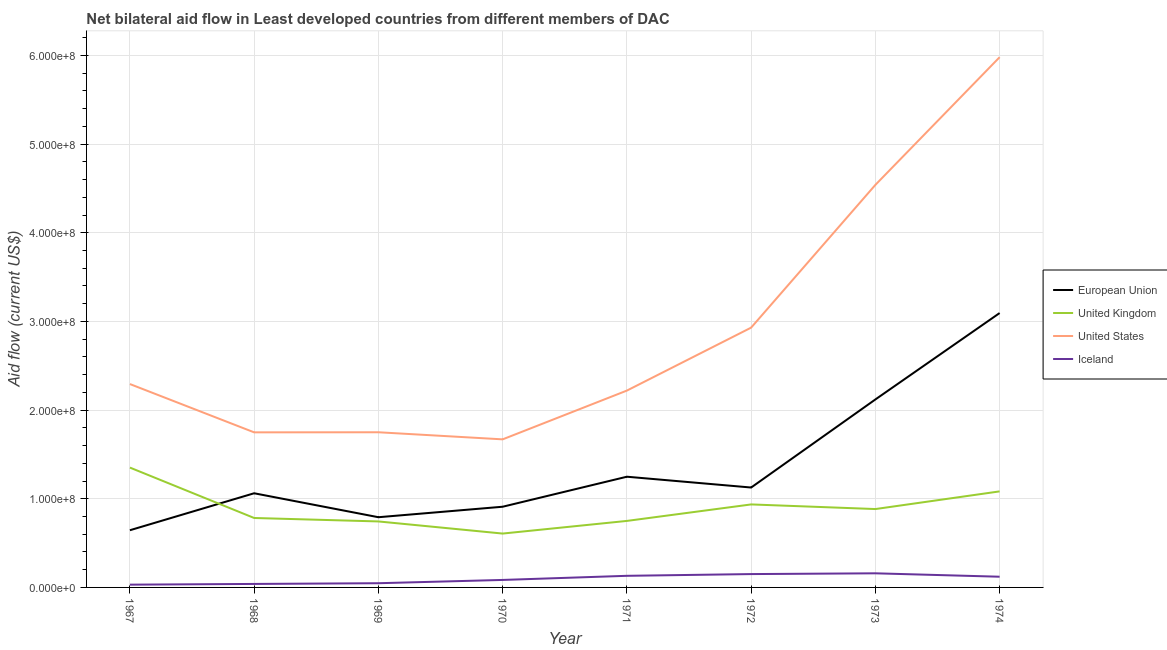How many different coloured lines are there?
Make the answer very short. 4. Does the line corresponding to amount of aid given by us intersect with the line corresponding to amount of aid given by uk?
Ensure brevity in your answer.  No. What is the amount of aid given by us in 1969?
Provide a succinct answer. 1.75e+08. Across all years, what is the maximum amount of aid given by us?
Provide a short and direct response. 5.98e+08. Across all years, what is the minimum amount of aid given by eu?
Offer a terse response. 6.45e+07. In which year was the amount of aid given by uk minimum?
Give a very brief answer. 1970. What is the total amount of aid given by us in the graph?
Provide a succinct answer. 2.31e+09. What is the difference between the amount of aid given by eu in 1973 and that in 1974?
Your answer should be very brief. -9.74e+07. What is the difference between the amount of aid given by us in 1969 and the amount of aid given by eu in 1973?
Offer a very short reply. -3.70e+07. What is the average amount of aid given by iceland per year?
Provide a succinct answer. 9.55e+06. In the year 1974, what is the difference between the amount of aid given by iceland and amount of aid given by uk?
Your answer should be compact. -9.62e+07. What is the ratio of the amount of aid given by eu in 1967 to that in 1974?
Provide a short and direct response. 0.21. Is the amount of aid given by eu in 1969 less than that in 1973?
Ensure brevity in your answer.  Yes. Is the difference between the amount of aid given by eu in 1973 and 1974 greater than the difference between the amount of aid given by us in 1973 and 1974?
Give a very brief answer. Yes. What is the difference between the highest and the second highest amount of aid given by eu?
Your answer should be compact. 9.74e+07. What is the difference between the highest and the lowest amount of aid given by uk?
Keep it short and to the point. 7.44e+07. Is the sum of the amount of aid given by eu in 1968 and 1974 greater than the maximum amount of aid given by uk across all years?
Give a very brief answer. Yes. Is it the case that in every year, the sum of the amount of aid given by us and amount of aid given by uk is greater than the sum of amount of aid given by iceland and amount of aid given by eu?
Provide a short and direct response. No. How many years are there in the graph?
Keep it short and to the point. 8. What is the difference between two consecutive major ticks on the Y-axis?
Offer a terse response. 1.00e+08. Are the values on the major ticks of Y-axis written in scientific E-notation?
Offer a very short reply. Yes. Does the graph contain any zero values?
Make the answer very short. No. What is the title of the graph?
Your response must be concise. Net bilateral aid flow in Least developed countries from different members of DAC. Does "Fourth 20% of population" appear as one of the legend labels in the graph?
Ensure brevity in your answer.  No. What is the Aid flow (current US$) in European Union in 1967?
Your response must be concise. 6.45e+07. What is the Aid flow (current US$) in United Kingdom in 1967?
Keep it short and to the point. 1.35e+08. What is the Aid flow (current US$) of United States in 1967?
Provide a succinct answer. 2.29e+08. What is the Aid flow (current US$) of Iceland in 1967?
Give a very brief answer. 3.12e+06. What is the Aid flow (current US$) of European Union in 1968?
Your response must be concise. 1.06e+08. What is the Aid flow (current US$) in United Kingdom in 1968?
Give a very brief answer. 7.83e+07. What is the Aid flow (current US$) in United States in 1968?
Ensure brevity in your answer.  1.75e+08. What is the Aid flow (current US$) in Iceland in 1968?
Keep it short and to the point. 3.94e+06. What is the Aid flow (current US$) in European Union in 1969?
Offer a very short reply. 7.92e+07. What is the Aid flow (current US$) of United Kingdom in 1969?
Give a very brief answer. 7.44e+07. What is the Aid flow (current US$) of United States in 1969?
Offer a very short reply. 1.75e+08. What is the Aid flow (current US$) of Iceland in 1969?
Provide a short and direct response. 4.74e+06. What is the Aid flow (current US$) in European Union in 1970?
Keep it short and to the point. 9.10e+07. What is the Aid flow (current US$) of United Kingdom in 1970?
Your answer should be very brief. 6.08e+07. What is the Aid flow (current US$) in United States in 1970?
Give a very brief answer. 1.67e+08. What is the Aid flow (current US$) of Iceland in 1970?
Offer a terse response. 8.45e+06. What is the Aid flow (current US$) of European Union in 1971?
Provide a short and direct response. 1.25e+08. What is the Aid flow (current US$) of United Kingdom in 1971?
Offer a terse response. 7.50e+07. What is the Aid flow (current US$) of United States in 1971?
Provide a short and direct response. 2.22e+08. What is the Aid flow (current US$) of Iceland in 1971?
Make the answer very short. 1.31e+07. What is the Aid flow (current US$) of European Union in 1972?
Your answer should be compact. 1.13e+08. What is the Aid flow (current US$) of United Kingdom in 1972?
Provide a short and direct response. 9.36e+07. What is the Aid flow (current US$) of United States in 1972?
Your answer should be very brief. 2.93e+08. What is the Aid flow (current US$) in Iceland in 1972?
Your answer should be compact. 1.50e+07. What is the Aid flow (current US$) of European Union in 1973?
Your answer should be very brief. 2.12e+08. What is the Aid flow (current US$) of United Kingdom in 1973?
Provide a succinct answer. 8.84e+07. What is the Aid flow (current US$) of United States in 1973?
Provide a short and direct response. 4.54e+08. What is the Aid flow (current US$) of Iceland in 1973?
Your answer should be compact. 1.59e+07. What is the Aid flow (current US$) in European Union in 1974?
Provide a succinct answer. 3.09e+08. What is the Aid flow (current US$) of United Kingdom in 1974?
Your answer should be very brief. 1.08e+08. What is the Aid flow (current US$) in United States in 1974?
Provide a succinct answer. 5.98e+08. What is the Aid flow (current US$) in Iceland in 1974?
Your answer should be compact. 1.21e+07. Across all years, what is the maximum Aid flow (current US$) of European Union?
Ensure brevity in your answer.  3.09e+08. Across all years, what is the maximum Aid flow (current US$) of United Kingdom?
Offer a terse response. 1.35e+08. Across all years, what is the maximum Aid flow (current US$) in United States?
Ensure brevity in your answer.  5.98e+08. Across all years, what is the maximum Aid flow (current US$) in Iceland?
Provide a short and direct response. 1.59e+07. Across all years, what is the minimum Aid flow (current US$) of European Union?
Give a very brief answer. 6.45e+07. Across all years, what is the minimum Aid flow (current US$) in United Kingdom?
Offer a terse response. 6.08e+07. Across all years, what is the minimum Aid flow (current US$) in United States?
Make the answer very short. 1.67e+08. Across all years, what is the minimum Aid flow (current US$) of Iceland?
Provide a short and direct response. 3.12e+06. What is the total Aid flow (current US$) of European Union in the graph?
Provide a short and direct response. 1.10e+09. What is the total Aid flow (current US$) in United Kingdom in the graph?
Offer a very short reply. 7.14e+08. What is the total Aid flow (current US$) in United States in the graph?
Give a very brief answer. 2.31e+09. What is the total Aid flow (current US$) of Iceland in the graph?
Make the answer very short. 7.64e+07. What is the difference between the Aid flow (current US$) in European Union in 1967 and that in 1968?
Offer a terse response. -4.17e+07. What is the difference between the Aid flow (current US$) of United Kingdom in 1967 and that in 1968?
Give a very brief answer. 5.68e+07. What is the difference between the Aid flow (current US$) in United States in 1967 and that in 1968?
Your answer should be very brief. 5.45e+07. What is the difference between the Aid flow (current US$) in Iceland in 1967 and that in 1968?
Give a very brief answer. -8.20e+05. What is the difference between the Aid flow (current US$) in European Union in 1967 and that in 1969?
Provide a succinct answer. -1.47e+07. What is the difference between the Aid flow (current US$) in United Kingdom in 1967 and that in 1969?
Your answer should be compact. 6.07e+07. What is the difference between the Aid flow (current US$) of United States in 1967 and that in 1969?
Offer a very short reply. 5.44e+07. What is the difference between the Aid flow (current US$) in Iceland in 1967 and that in 1969?
Provide a succinct answer. -1.62e+06. What is the difference between the Aid flow (current US$) of European Union in 1967 and that in 1970?
Your response must be concise. -2.65e+07. What is the difference between the Aid flow (current US$) in United Kingdom in 1967 and that in 1970?
Make the answer very short. 7.44e+07. What is the difference between the Aid flow (current US$) in United States in 1967 and that in 1970?
Your response must be concise. 6.24e+07. What is the difference between the Aid flow (current US$) of Iceland in 1967 and that in 1970?
Keep it short and to the point. -5.33e+06. What is the difference between the Aid flow (current US$) of European Union in 1967 and that in 1971?
Give a very brief answer. -6.04e+07. What is the difference between the Aid flow (current US$) of United Kingdom in 1967 and that in 1971?
Provide a short and direct response. 6.02e+07. What is the difference between the Aid flow (current US$) of United States in 1967 and that in 1971?
Provide a short and direct response. 7.37e+06. What is the difference between the Aid flow (current US$) in Iceland in 1967 and that in 1971?
Offer a very short reply. -9.97e+06. What is the difference between the Aid flow (current US$) in European Union in 1967 and that in 1972?
Offer a very short reply. -4.82e+07. What is the difference between the Aid flow (current US$) in United Kingdom in 1967 and that in 1972?
Provide a short and direct response. 4.16e+07. What is the difference between the Aid flow (current US$) in United States in 1967 and that in 1972?
Ensure brevity in your answer.  -6.36e+07. What is the difference between the Aid flow (current US$) of Iceland in 1967 and that in 1972?
Provide a succinct answer. -1.19e+07. What is the difference between the Aid flow (current US$) in European Union in 1967 and that in 1973?
Ensure brevity in your answer.  -1.47e+08. What is the difference between the Aid flow (current US$) in United Kingdom in 1967 and that in 1973?
Give a very brief answer. 4.68e+07. What is the difference between the Aid flow (current US$) of United States in 1967 and that in 1973?
Ensure brevity in your answer.  -2.25e+08. What is the difference between the Aid flow (current US$) in Iceland in 1967 and that in 1973?
Offer a very short reply. -1.28e+07. What is the difference between the Aid flow (current US$) in European Union in 1967 and that in 1974?
Provide a short and direct response. -2.45e+08. What is the difference between the Aid flow (current US$) of United Kingdom in 1967 and that in 1974?
Keep it short and to the point. 2.68e+07. What is the difference between the Aid flow (current US$) in United States in 1967 and that in 1974?
Your answer should be compact. -3.69e+08. What is the difference between the Aid flow (current US$) in Iceland in 1967 and that in 1974?
Provide a succinct answer. -8.95e+06. What is the difference between the Aid flow (current US$) of European Union in 1968 and that in 1969?
Your answer should be compact. 2.70e+07. What is the difference between the Aid flow (current US$) of United Kingdom in 1968 and that in 1969?
Offer a terse response. 3.90e+06. What is the difference between the Aid flow (current US$) in Iceland in 1968 and that in 1969?
Ensure brevity in your answer.  -8.00e+05. What is the difference between the Aid flow (current US$) of European Union in 1968 and that in 1970?
Offer a terse response. 1.52e+07. What is the difference between the Aid flow (current US$) of United Kingdom in 1968 and that in 1970?
Offer a very short reply. 1.76e+07. What is the difference between the Aid flow (current US$) of United States in 1968 and that in 1970?
Give a very brief answer. 7.90e+06. What is the difference between the Aid flow (current US$) of Iceland in 1968 and that in 1970?
Offer a terse response. -4.51e+06. What is the difference between the Aid flow (current US$) of European Union in 1968 and that in 1971?
Offer a very short reply. -1.87e+07. What is the difference between the Aid flow (current US$) of United Kingdom in 1968 and that in 1971?
Your response must be concise. 3.31e+06. What is the difference between the Aid flow (current US$) in United States in 1968 and that in 1971?
Keep it short and to the point. -4.71e+07. What is the difference between the Aid flow (current US$) in Iceland in 1968 and that in 1971?
Make the answer very short. -9.15e+06. What is the difference between the Aid flow (current US$) of European Union in 1968 and that in 1972?
Offer a very short reply. -6.47e+06. What is the difference between the Aid flow (current US$) in United Kingdom in 1968 and that in 1972?
Keep it short and to the point. -1.53e+07. What is the difference between the Aid flow (current US$) in United States in 1968 and that in 1972?
Your answer should be very brief. -1.18e+08. What is the difference between the Aid flow (current US$) in Iceland in 1968 and that in 1972?
Your response must be concise. -1.11e+07. What is the difference between the Aid flow (current US$) in European Union in 1968 and that in 1973?
Your answer should be compact. -1.06e+08. What is the difference between the Aid flow (current US$) in United Kingdom in 1968 and that in 1973?
Your response must be concise. -1.01e+07. What is the difference between the Aid flow (current US$) of United States in 1968 and that in 1973?
Your answer should be compact. -2.79e+08. What is the difference between the Aid flow (current US$) of Iceland in 1968 and that in 1973?
Ensure brevity in your answer.  -1.20e+07. What is the difference between the Aid flow (current US$) in European Union in 1968 and that in 1974?
Give a very brief answer. -2.03e+08. What is the difference between the Aid flow (current US$) of United Kingdom in 1968 and that in 1974?
Keep it short and to the point. -3.00e+07. What is the difference between the Aid flow (current US$) of United States in 1968 and that in 1974?
Your answer should be compact. -4.23e+08. What is the difference between the Aid flow (current US$) of Iceland in 1968 and that in 1974?
Give a very brief answer. -8.13e+06. What is the difference between the Aid flow (current US$) of European Union in 1969 and that in 1970?
Your answer should be compact. -1.18e+07. What is the difference between the Aid flow (current US$) of United Kingdom in 1969 and that in 1970?
Your response must be concise. 1.37e+07. What is the difference between the Aid flow (current US$) in United States in 1969 and that in 1970?
Keep it short and to the point. 8.00e+06. What is the difference between the Aid flow (current US$) of Iceland in 1969 and that in 1970?
Make the answer very short. -3.71e+06. What is the difference between the Aid flow (current US$) of European Union in 1969 and that in 1971?
Keep it short and to the point. -4.57e+07. What is the difference between the Aid flow (current US$) of United Kingdom in 1969 and that in 1971?
Provide a succinct answer. -5.90e+05. What is the difference between the Aid flow (current US$) in United States in 1969 and that in 1971?
Your response must be concise. -4.70e+07. What is the difference between the Aid flow (current US$) of Iceland in 1969 and that in 1971?
Provide a short and direct response. -8.35e+06. What is the difference between the Aid flow (current US$) of European Union in 1969 and that in 1972?
Your answer should be very brief. -3.35e+07. What is the difference between the Aid flow (current US$) in United Kingdom in 1969 and that in 1972?
Your response must be concise. -1.92e+07. What is the difference between the Aid flow (current US$) of United States in 1969 and that in 1972?
Make the answer very short. -1.18e+08. What is the difference between the Aid flow (current US$) of Iceland in 1969 and that in 1972?
Make the answer very short. -1.03e+07. What is the difference between the Aid flow (current US$) in European Union in 1969 and that in 1973?
Your answer should be very brief. -1.33e+08. What is the difference between the Aid flow (current US$) in United Kingdom in 1969 and that in 1973?
Provide a succinct answer. -1.40e+07. What is the difference between the Aid flow (current US$) in United States in 1969 and that in 1973?
Your answer should be very brief. -2.79e+08. What is the difference between the Aid flow (current US$) of Iceland in 1969 and that in 1973?
Provide a succinct answer. -1.12e+07. What is the difference between the Aid flow (current US$) of European Union in 1969 and that in 1974?
Ensure brevity in your answer.  -2.30e+08. What is the difference between the Aid flow (current US$) in United Kingdom in 1969 and that in 1974?
Your answer should be compact. -3.39e+07. What is the difference between the Aid flow (current US$) in United States in 1969 and that in 1974?
Your answer should be compact. -4.23e+08. What is the difference between the Aid flow (current US$) of Iceland in 1969 and that in 1974?
Give a very brief answer. -7.33e+06. What is the difference between the Aid flow (current US$) in European Union in 1970 and that in 1971?
Offer a very short reply. -3.38e+07. What is the difference between the Aid flow (current US$) of United Kingdom in 1970 and that in 1971?
Your answer should be compact. -1.43e+07. What is the difference between the Aid flow (current US$) of United States in 1970 and that in 1971?
Ensure brevity in your answer.  -5.50e+07. What is the difference between the Aid flow (current US$) of Iceland in 1970 and that in 1971?
Your answer should be very brief. -4.64e+06. What is the difference between the Aid flow (current US$) in European Union in 1970 and that in 1972?
Your response must be concise. -2.17e+07. What is the difference between the Aid flow (current US$) of United Kingdom in 1970 and that in 1972?
Offer a very short reply. -3.29e+07. What is the difference between the Aid flow (current US$) in United States in 1970 and that in 1972?
Make the answer very short. -1.26e+08. What is the difference between the Aid flow (current US$) of Iceland in 1970 and that in 1972?
Make the answer very short. -6.60e+06. What is the difference between the Aid flow (current US$) of European Union in 1970 and that in 1973?
Offer a very short reply. -1.21e+08. What is the difference between the Aid flow (current US$) of United Kingdom in 1970 and that in 1973?
Provide a succinct answer. -2.76e+07. What is the difference between the Aid flow (current US$) of United States in 1970 and that in 1973?
Your answer should be very brief. -2.87e+08. What is the difference between the Aid flow (current US$) of Iceland in 1970 and that in 1973?
Your answer should be compact. -7.46e+06. What is the difference between the Aid flow (current US$) in European Union in 1970 and that in 1974?
Give a very brief answer. -2.18e+08. What is the difference between the Aid flow (current US$) in United Kingdom in 1970 and that in 1974?
Ensure brevity in your answer.  -4.76e+07. What is the difference between the Aid flow (current US$) in United States in 1970 and that in 1974?
Provide a succinct answer. -4.31e+08. What is the difference between the Aid flow (current US$) in Iceland in 1970 and that in 1974?
Your answer should be very brief. -3.62e+06. What is the difference between the Aid flow (current US$) in European Union in 1971 and that in 1972?
Give a very brief answer. 1.22e+07. What is the difference between the Aid flow (current US$) of United Kingdom in 1971 and that in 1972?
Your answer should be very brief. -1.86e+07. What is the difference between the Aid flow (current US$) in United States in 1971 and that in 1972?
Make the answer very short. -7.10e+07. What is the difference between the Aid flow (current US$) of Iceland in 1971 and that in 1972?
Offer a terse response. -1.96e+06. What is the difference between the Aid flow (current US$) in European Union in 1971 and that in 1973?
Offer a terse response. -8.71e+07. What is the difference between the Aid flow (current US$) of United Kingdom in 1971 and that in 1973?
Keep it short and to the point. -1.34e+07. What is the difference between the Aid flow (current US$) of United States in 1971 and that in 1973?
Provide a succinct answer. -2.32e+08. What is the difference between the Aid flow (current US$) of Iceland in 1971 and that in 1973?
Keep it short and to the point. -2.82e+06. What is the difference between the Aid flow (current US$) in European Union in 1971 and that in 1974?
Give a very brief answer. -1.85e+08. What is the difference between the Aid flow (current US$) of United Kingdom in 1971 and that in 1974?
Keep it short and to the point. -3.33e+07. What is the difference between the Aid flow (current US$) in United States in 1971 and that in 1974?
Provide a short and direct response. -3.76e+08. What is the difference between the Aid flow (current US$) of Iceland in 1971 and that in 1974?
Give a very brief answer. 1.02e+06. What is the difference between the Aid flow (current US$) in European Union in 1972 and that in 1973?
Your answer should be very brief. -9.93e+07. What is the difference between the Aid flow (current US$) in United Kingdom in 1972 and that in 1973?
Your answer should be compact. 5.22e+06. What is the difference between the Aid flow (current US$) of United States in 1972 and that in 1973?
Make the answer very short. -1.61e+08. What is the difference between the Aid flow (current US$) in Iceland in 1972 and that in 1973?
Make the answer very short. -8.60e+05. What is the difference between the Aid flow (current US$) in European Union in 1972 and that in 1974?
Ensure brevity in your answer.  -1.97e+08. What is the difference between the Aid flow (current US$) in United Kingdom in 1972 and that in 1974?
Your answer should be very brief. -1.47e+07. What is the difference between the Aid flow (current US$) of United States in 1972 and that in 1974?
Provide a short and direct response. -3.05e+08. What is the difference between the Aid flow (current US$) of Iceland in 1972 and that in 1974?
Keep it short and to the point. 2.98e+06. What is the difference between the Aid flow (current US$) in European Union in 1973 and that in 1974?
Offer a terse response. -9.74e+07. What is the difference between the Aid flow (current US$) of United Kingdom in 1973 and that in 1974?
Give a very brief answer. -1.99e+07. What is the difference between the Aid flow (current US$) in United States in 1973 and that in 1974?
Your response must be concise. -1.44e+08. What is the difference between the Aid flow (current US$) in Iceland in 1973 and that in 1974?
Provide a succinct answer. 3.84e+06. What is the difference between the Aid flow (current US$) in European Union in 1967 and the Aid flow (current US$) in United Kingdom in 1968?
Keep it short and to the point. -1.38e+07. What is the difference between the Aid flow (current US$) of European Union in 1967 and the Aid flow (current US$) of United States in 1968?
Ensure brevity in your answer.  -1.10e+08. What is the difference between the Aid flow (current US$) in European Union in 1967 and the Aid flow (current US$) in Iceland in 1968?
Provide a succinct answer. 6.06e+07. What is the difference between the Aid flow (current US$) in United Kingdom in 1967 and the Aid flow (current US$) in United States in 1968?
Offer a terse response. -3.97e+07. What is the difference between the Aid flow (current US$) of United Kingdom in 1967 and the Aid flow (current US$) of Iceland in 1968?
Offer a terse response. 1.31e+08. What is the difference between the Aid flow (current US$) in United States in 1967 and the Aid flow (current US$) in Iceland in 1968?
Your answer should be very brief. 2.25e+08. What is the difference between the Aid flow (current US$) of European Union in 1967 and the Aid flow (current US$) of United Kingdom in 1969?
Offer a very short reply. -9.91e+06. What is the difference between the Aid flow (current US$) of European Union in 1967 and the Aid flow (current US$) of United States in 1969?
Your answer should be compact. -1.10e+08. What is the difference between the Aid flow (current US$) of European Union in 1967 and the Aid flow (current US$) of Iceland in 1969?
Provide a succinct answer. 5.98e+07. What is the difference between the Aid flow (current US$) of United Kingdom in 1967 and the Aid flow (current US$) of United States in 1969?
Offer a terse response. -3.98e+07. What is the difference between the Aid flow (current US$) in United Kingdom in 1967 and the Aid flow (current US$) in Iceland in 1969?
Make the answer very short. 1.30e+08. What is the difference between the Aid flow (current US$) in United States in 1967 and the Aid flow (current US$) in Iceland in 1969?
Provide a succinct answer. 2.25e+08. What is the difference between the Aid flow (current US$) in European Union in 1967 and the Aid flow (current US$) in United Kingdom in 1970?
Provide a succinct answer. 3.76e+06. What is the difference between the Aid flow (current US$) in European Union in 1967 and the Aid flow (current US$) in United States in 1970?
Offer a very short reply. -1.02e+08. What is the difference between the Aid flow (current US$) of European Union in 1967 and the Aid flow (current US$) of Iceland in 1970?
Your response must be concise. 5.61e+07. What is the difference between the Aid flow (current US$) of United Kingdom in 1967 and the Aid flow (current US$) of United States in 1970?
Make the answer very short. -3.18e+07. What is the difference between the Aid flow (current US$) of United Kingdom in 1967 and the Aid flow (current US$) of Iceland in 1970?
Offer a very short reply. 1.27e+08. What is the difference between the Aid flow (current US$) of United States in 1967 and the Aid flow (current US$) of Iceland in 1970?
Ensure brevity in your answer.  2.21e+08. What is the difference between the Aid flow (current US$) in European Union in 1967 and the Aid flow (current US$) in United Kingdom in 1971?
Give a very brief answer. -1.05e+07. What is the difference between the Aid flow (current US$) of European Union in 1967 and the Aid flow (current US$) of United States in 1971?
Keep it short and to the point. -1.57e+08. What is the difference between the Aid flow (current US$) in European Union in 1967 and the Aid flow (current US$) in Iceland in 1971?
Your answer should be very brief. 5.14e+07. What is the difference between the Aid flow (current US$) in United Kingdom in 1967 and the Aid flow (current US$) in United States in 1971?
Offer a terse response. -8.68e+07. What is the difference between the Aid flow (current US$) in United Kingdom in 1967 and the Aid flow (current US$) in Iceland in 1971?
Your answer should be very brief. 1.22e+08. What is the difference between the Aid flow (current US$) in United States in 1967 and the Aid flow (current US$) in Iceland in 1971?
Ensure brevity in your answer.  2.16e+08. What is the difference between the Aid flow (current US$) in European Union in 1967 and the Aid flow (current US$) in United Kingdom in 1972?
Offer a terse response. -2.91e+07. What is the difference between the Aid flow (current US$) of European Union in 1967 and the Aid flow (current US$) of United States in 1972?
Your response must be concise. -2.28e+08. What is the difference between the Aid flow (current US$) in European Union in 1967 and the Aid flow (current US$) in Iceland in 1972?
Provide a short and direct response. 4.95e+07. What is the difference between the Aid flow (current US$) in United Kingdom in 1967 and the Aid flow (current US$) in United States in 1972?
Give a very brief answer. -1.58e+08. What is the difference between the Aid flow (current US$) in United Kingdom in 1967 and the Aid flow (current US$) in Iceland in 1972?
Your response must be concise. 1.20e+08. What is the difference between the Aid flow (current US$) of United States in 1967 and the Aid flow (current US$) of Iceland in 1972?
Offer a very short reply. 2.14e+08. What is the difference between the Aid flow (current US$) of European Union in 1967 and the Aid flow (current US$) of United Kingdom in 1973?
Your answer should be compact. -2.39e+07. What is the difference between the Aid flow (current US$) in European Union in 1967 and the Aid flow (current US$) in United States in 1973?
Ensure brevity in your answer.  -3.89e+08. What is the difference between the Aid flow (current US$) of European Union in 1967 and the Aid flow (current US$) of Iceland in 1973?
Keep it short and to the point. 4.86e+07. What is the difference between the Aid flow (current US$) in United Kingdom in 1967 and the Aid flow (current US$) in United States in 1973?
Give a very brief answer. -3.19e+08. What is the difference between the Aid flow (current US$) of United Kingdom in 1967 and the Aid flow (current US$) of Iceland in 1973?
Provide a short and direct response. 1.19e+08. What is the difference between the Aid flow (current US$) of United States in 1967 and the Aid flow (current US$) of Iceland in 1973?
Your response must be concise. 2.13e+08. What is the difference between the Aid flow (current US$) in European Union in 1967 and the Aid flow (current US$) in United Kingdom in 1974?
Provide a succinct answer. -4.38e+07. What is the difference between the Aid flow (current US$) of European Union in 1967 and the Aid flow (current US$) of United States in 1974?
Provide a succinct answer. -5.33e+08. What is the difference between the Aid flow (current US$) of European Union in 1967 and the Aid flow (current US$) of Iceland in 1974?
Your answer should be compact. 5.24e+07. What is the difference between the Aid flow (current US$) of United Kingdom in 1967 and the Aid flow (current US$) of United States in 1974?
Keep it short and to the point. -4.63e+08. What is the difference between the Aid flow (current US$) in United Kingdom in 1967 and the Aid flow (current US$) in Iceland in 1974?
Make the answer very short. 1.23e+08. What is the difference between the Aid flow (current US$) of United States in 1967 and the Aid flow (current US$) of Iceland in 1974?
Your answer should be very brief. 2.17e+08. What is the difference between the Aid flow (current US$) in European Union in 1968 and the Aid flow (current US$) in United Kingdom in 1969?
Offer a very short reply. 3.18e+07. What is the difference between the Aid flow (current US$) of European Union in 1968 and the Aid flow (current US$) of United States in 1969?
Your answer should be very brief. -6.88e+07. What is the difference between the Aid flow (current US$) of European Union in 1968 and the Aid flow (current US$) of Iceland in 1969?
Provide a short and direct response. 1.01e+08. What is the difference between the Aid flow (current US$) of United Kingdom in 1968 and the Aid flow (current US$) of United States in 1969?
Offer a terse response. -9.67e+07. What is the difference between the Aid flow (current US$) in United Kingdom in 1968 and the Aid flow (current US$) in Iceland in 1969?
Keep it short and to the point. 7.36e+07. What is the difference between the Aid flow (current US$) in United States in 1968 and the Aid flow (current US$) in Iceland in 1969?
Provide a succinct answer. 1.70e+08. What is the difference between the Aid flow (current US$) of European Union in 1968 and the Aid flow (current US$) of United Kingdom in 1970?
Ensure brevity in your answer.  4.54e+07. What is the difference between the Aid flow (current US$) of European Union in 1968 and the Aid flow (current US$) of United States in 1970?
Give a very brief answer. -6.08e+07. What is the difference between the Aid flow (current US$) of European Union in 1968 and the Aid flow (current US$) of Iceland in 1970?
Your answer should be very brief. 9.78e+07. What is the difference between the Aid flow (current US$) in United Kingdom in 1968 and the Aid flow (current US$) in United States in 1970?
Make the answer very short. -8.87e+07. What is the difference between the Aid flow (current US$) of United Kingdom in 1968 and the Aid flow (current US$) of Iceland in 1970?
Provide a short and direct response. 6.99e+07. What is the difference between the Aid flow (current US$) of United States in 1968 and the Aid flow (current US$) of Iceland in 1970?
Your response must be concise. 1.66e+08. What is the difference between the Aid flow (current US$) in European Union in 1968 and the Aid flow (current US$) in United Kingdom in 1971?
Give a very brief answer. 3.12e+07. What is the difference between the Aid flow (current US$) in European Union in 1968 and the Aid flow (current US$) in United States in 1971?
Give a very brief answer. -1.16e+08. What is the difference between the Aid flow (current US$) of European Union in 1968 and the Aid flow (current US$) of Iceland in 1971?
Your answer should be compact. 9.31e+07. What is the difference between the Aid flow (current US$) in United Kingdom in 1968 and the Aid flow (current US$) in United States in 1971?
Your answer should be very brief. -1.44e+08. What is the difference between the Aid flow (current US$) in United Kingdom in 1968 and the Aid flow (current US$) in Iceland in 1971?
Keep it short and to the point. 6.52e+07. What is the difference between the Aid flow (current US$) of United States in 1968 and the Aid flow (current US$) of Iceland in 1971?
Make the answer very short. 1.62e+08. What is the difference between the Aid flow (current US$) in European Union in 1968 and the Aid flow (current US$) in United Kingdom in 1972?
Your response must be concise. 1.26e+07. What is the difference between the Aid flow (current US$) of European Union in 1968 and the Aid flow (current US$) of United States in 1972?
Offer a terse response. -1.87e+08. What is the difference between the Aid flow (current US$) in European Union in 1968 and the Aid flow (current US$) in Iceland in 1972?
Give a very brief answer. 9.12e+07. What is the difference between the Aid flow (current US$) in United Kingdom in 1968 and the Aid flow (current US$) in United States in 1972?
Offer a very short reply. -2.15e+08. What is the difference between the Aid flow (current US$) in United Kingdom in 1968 and the Aid flow (current US$) in Iceland in 1972?
Ensure brevity in your answer.  6.33e+07. What is the difference between the Aid flow (current US$) in United States in 1968 and the Aid flow (current US$) in Iceland in 1972?
Give a very brief answer. 1.60e+08. What is the difference between the Aid flow (current US$) of European Union in 1968 and the Aid flow (current US$) of United Kingdom in 1973?
Ensure brevity in your answer.  1.78e+07. What is the difference between the Aid flow (current US$) of European Union in 1968 and the Aid flow (current US$) of United States in 1973?
Your answer should be very brief. -3.48e+08. What is the difference between the Aid flow (current US$) of European Union in 1968 and the Aid flow (current US$) of Iceland in 1973?
Provide a short and direct response. 9.03e+07. What is the difference between the Aid flow (current US$) in United Kingdom in 1968 and the Aid flow (current US$) in United States in 1973?
Ensure brevity in your answer.  -3.76e+08. What is the difference between the Aid flow (current US$) in United Kingdom in 1968 and the Aid flow (current US$) in Iceland in 1973?
Keep it short and to the point. 6.24e+07. What is the difference between the Aid flow (current US$) in United States in 1968 and the Aid flow (current US$) in Iceland in 1973?
Offer a terse response. 1.59e+08. What is the difference between the Aid flow (current US$) of European Union in 1968 and the Aid flow (current US$) of United Kingdom in 1974?
Offer a very short reply. -2.12e+06. What is the difference between the Aid flow (current US$) in European Union in 1968 and the Aid flow (current US$) in United States in 1974?
Your answer should be compact. -4.92e+08. What is the difference between the Aid flow (current US$) in European Union in 1968 and the Aid flow (current US$) in Iceland in 1974?
Provide a succinct answer. 9.41e+07. What is the difference between the Aid flow (current US$) of United Kingdom in 1968 and the Aid flow (current US$) of United States in 1974?
Your answer should be very brief. -5.20e+08. What is the difference between the Aid flow (current US$) of United Kingdom in 1968 and the Aid flow (current US$) of Iceland in 1974?
Keep it short and to the point. 6.62e+07. What is the difference between the Aid flow (current US$) in United States in 1968 and the Aid flow (current US$) in Iceland in 1974?
Your answer should be very brief. 1.63e+08. What is the difference between the Aid flow (current US$) of European Union in 1969 and the Aid flow (current US$) of United Kingdom in 1970?
Provide a short and direct response. 1.84e+07. What is the difference between the Aid flow (current US$) in European Union in 1969 and the Aid flow (current US$) in United States in 1970?
Make the answer very short. -8.78e+07. What is the difference between the Aid flow (current US$) in European Union in 1969 and the Aid flow (current US$) in Iceland in 1970?
Your answer should be compact. 7.07e+07. What is the difference between the Aid flow (current US$) in United Kingdom in 1969 and the Aid flow (current US$) in United States in 1970?
Give a very brief answer. -9.26e+07. What is the difference between the Aid flow (current US$) of United Kingdom in 1969 and the Aid flow (current US$) of Iceland in 1970?
Provide a short and direct response. 6.60e+07. What is the difference between the Aid flow (current US$) of United States in 1969 and the Aid flow (current US$) of Iceland in 1970?
Offer a terse response. 1.67e+08. What is the difference between the Aid flow (current US$) of European Union in 1969 and the Aid flow (current US$) of United Kingdom in 1971?
Offer a terse response. 4.17e+06. What is the difference between the Aid flow (current US$) of European Union in 1969 and the Aid flow (current US$) of United States in 1971?
Ensure brevity in your answer.  -1.43e+08. What is the difference between the Aid flow (current US$) of European Union in 1969 and the Aid flow (current US$) of Iceland in 1971?
Keep it short and to the point. 6.61e+07. What is the difference between the Aid flow (current US$) of United Kingdom in 1969 and the Aid flow (current US$) of United States in 1971?
Provide a short and direct response. -1.48e+08. What is the difference between the Aid flow (current US$) of United Kingdom in 1969 and the Aid flow (current US$) of Iceland in 1971?
Keep it short and to the point. 6.13e+07. What is the difference between the Aid flow (current US$) of United States in 1969 and the Aid flow (current US$) of Iceland in 1971?
Offer a terse response. 1.62e+08. What is the difference between the Aid flow (current US$) of European Union in 1969 and the Aid flow (current US$) of United Kingdom in 1972?
Make the answer very short. -1.44e+07. What is the difference between the Aid flow (current US$) in European Union in 1969 and the Aid flow (current US$) in United States in 1972?
Your answer should be very brief. -2.14e+08. What is the difference between the Aid flow (current US$) in European Union in 1969 and the Aid flow (current US$) in Iceland in 1972?
Provide a succinct answer. 6.41e+07. What is the difference between the Aid flow (current US$) of United Kingdom in 1969 and the Aid flow (current US$) of United States in 1972?
Provide a succinct answer. -2.19e+08. What is the difference between the Aid flow (current US$) of United Kingdom in 1969 and the Aid flow (current US$) of Iceland in 1972?
Provide a succinct answer. 5.94e+07. What is the difference between the Aid flow (current US$) in United States in 1969 and the Aid flow (current US$) in Iceland in 1972?
Ensure brevity in your answer.  1.60e+08. What is the difference between the Aid flow (current US$) in European Union in 1969 and the Aid flow (current US$) in United Kingdom in 1973?
Provide a succinct answer. -9.21e+06. What is the difference between the Aid flow (current US$) of European Union in 1969 and the Aid flow (current US$) of United States in 1973?
Provide a succinct answer. -3.75e+08. What is the difference between the Aid flow (current US$) in European Union in 1969 and the Aid flow (current US$) in Iceland in 1973?
Make the answer very short. 6.33e+07. What is the difference between the Aid flow (current US$) in United Kingdom in 1969 and the Aid flow (current US$) in United States in 1973?
Provide a succinct answer. -3.80e+08. What is the difference between the Aid flow (current US$) in United Kingdom in 1969 and the Aid flow (current US$) in Iceland in 1973?
Give a very brief answer. 5.85e+07. What is the difference between the Aid flow (current US$) of United States in 1969 and the Aid flow (current US$) of Iceland in 1973?
Provide a succinct answer. 1.59e+08. What is the difference between the Aid flow (current US$) of European Union in 1969 and the Aid flow (current US$) of United Kingdom in 1974?
Keep it short and to the point. -2.91e+07. What is the difference between the Aid flow (current US$) in European Union in 1969 and the Aid flow (current US$) in United States in 1974?
Your response must be concise. -5.19e+08. What is the difference between the Aid flow (current US$) of European Union in 1969 and the Aid flow (current US$) of Iceland in 1974?
Keep it short and to the point. 6.71e+07. What is the difference between the Aid flow (current US$) in United Kingdom in 1969 and the Aid flow (current US$) in United States in 1974?
Give a very brief answer. -5.24e+08. What is the difference between the Aid flow (current US$) of United Kingdom in 1969 and the Aid flow (current US$) of Iceland in 1974?
Make the answer very short. 6.24e+07. What is the difference between the Aid flow (current US$) in United States in 1969 and the Aid flow (current US$) in Iceland in 1974?
Your response must be concise. 1.63e+08. What is the difference between the Aid flow (current US$) of European Union in 1970 and the Aid flow (current US$) of United Kingdom in 1971?
Provide a succinct answer. 1.60e+07. What is the difference between the Aid flow (current US$) of European Union in 1970 and the Aid flow (current US$) of United States in 1971?
Offer a terse response. -1.31e+08. What is the difference between the Aid flow (current US$) in European Union in 1970 and the Aid flow (current US$) in Iceland in 1971?
Keep it short and to the point. 7.79e+07. What is the difference between the Aid flow (current US$) in United Kingdom in 1970 and the Aid flow (current US$) in United States in 1971?
Offer a terse response. -1.61e+08. What is the difference between the Aid flow (current US$) in United Kingdom in 1970 and the Aid flow (current US$) in Iceland in 1971?
Give a very brief answer. 4.77e+07. What is the difference between the Aid flow (current US$) of United States in 1970 and the Aid flow (current US$) of Iceland in 1971?
Your answer should be very brief. 1.54e+08. What is the difference between the Aid flow (current US$) of European Union in 1970 and the Aid flow (current US$) of United Kingdom in 1972?
Your answer should be compact. -2.60e+06. What is the difference between the Aid flow (current US$) of European Union in 1970 and the Aid flow (current US$) of United States in 1972?
Your answer should be compact. -2.02e+08. What is the difference between the Aid flow (current US$) of European Union in 1970 and the Aid flow (current US$) of Iceland in 1972?
Give a very brief answer. 7.60e+07. What is the difference between the Aid flow (current US$) of United Kingdom in 1970 and the Aid flow (current US$) of United States in 1972?
Provide a succinct answer. -2.32e+08. What is the difference between the Aid flow (current US$) of United Kingdom in 1970 and the Aid flow (current US$) of Iceland in 1972?
Your answer should be very brief. 4.57e+07. What is the difference between the Aid flow (current US$) in United States in 1970 and the Aid flow (current US$) in Iceland in 1972?
Your response must be concise. 1.52e+08. What is the difference between the Aid flow (current US$) in European Union in 1970 and the Aid flow (current US$) in United Kingdom in 1973?
Keep it short and to the point. 2.62e+06. What is the difference between the Aid flow (current US$) in European Union in 1970 and the Aid flow (current US$) in United States in 1973?
Offer a very short reply. -3.63e+08. What is the difference between the Aid flow (current US$) of European Union in 1970 and the Aid flow (current US$) of Iceland in 1973?
Provide a succinct answer. 7.51e+07. What is the difference between the Aid flow (current US$) in United Kingdom in 1970 and the Aid flow (current US$) in United States in 1973?
Give a very brief answer. -3.93e+08. What is the difference between the Aid flow (current US$) of United Kingdom in 1970 and the Aid flow (current US$) of Iceland in 1973?
Give a very brief answer. 4.48e+07. What is the difference between the Aid flow (current US$) in United States in 1970 and the Aid flow (current US$) in Iceland in 1973?
Offer a terse response. 1.51e+08. What is the difference between the Aid flow (current US$) of European Union in 1970 and the Aid flow (current US$) of United Kingdom in 1974?
Make the answer very short. -1.73e+07. What is the difference between the Aid flow (current US$) in European Union in 1970 and the Aid flow (current US$) in United States in 1974?
Your answer should be very brief. -5.07e+08. What is the difference between the Aid flow (current US$) of European Union in 1970 and the Aid flow (current US$) of Iceland in 1974?
Keep it short and to the point. 7.89e+07. What is the difference between the Aid flow (current US$) of United Kingdom in 1970 and the Aid flow (current US$) of United States in 1974?
Keep it short and to the point. -5.37e+08. What is the difference between the Aid flow (current US$) of United Kingdom in 1970 and the Aid flow (current US$) of Iceland in 1974?
Make the answer very short. 4.87e+07. What is the difference between the Aid flow (current US$) of United States in 1970 and the Aid flow (current US$) of Iceland in 1974?
Offer a terse response. 1.55e+08. What is the difference between the Aid flow (current US$) of European Union in 1971 and the Aid flow (current US$) of United Kingdom in 1972?
Ensure brevity in your answer.  3.12e+07. What is the difference between the Aid flow (current US$) in European Union in 1971 and the Aid flow (current US$) in United States in 1972?
Offer a terse response. -1.68e+08. What is the difference between the Aid flow (current US$) of European Union in 1971 and the Aid flow (current US$) of Iceland in 1972?
Your answer should be very brief. 1.10e+08. What is the difference between the Aid flow (current US$) in United Kingdom in 1971 and the Aid flow (current US$) in United States in 1972?
Offer a very short reply. -2.18e+08. What is the difference between the Aid flow (current US$) of United Kingdom in 1971 and the Aid flow (current US$) of Iceland in 1972?
Your answer should be very brief. 6.00e+07. What is the difference between the Aid flow (current US$) of United States in 1971 and the Aid flow (current US$) of Iceland in 1972?
Your answer should be compact. 2.07e+08. What is the difference between the Aid flow (current US$) of European Union in 1971 and the Aid flow (current US$) of United Kingdom in 1973?
Give a very brief answer. 3.65e+07. What is the difference between the Aid flow (current US$) in European Union in 1971 and the Aid flow (current US$) in United States in 1973?
Provide a short and direct response. -3.29e+08. What is the difference between the Aid flow (current US$) in European Union in 1971 and the Aid flow (current US$) in Iceland in 1973?
Provide a short and direct response. 1.09e+08. What is the difference between the Aid flow (current US$) of United Kingdom in 1971 and the Aid flow (current US$) of United States in 1973?
Give a very brief answer. -3.79e+08. What is the difference between the Aid flow (current US$) in United Kingdom in 1971 and the Aid flow (current US$) in Iceland in 1973?
Keep it short and to the point. 5.91e+07. What is the difference between the Aid flow (current US$) in United States in 1971 and the Aid flow (current US$) in Iceland in 1973?
Your answer should be compact. 2.06e+08. What is the difference between the Aid flow (current US$) in European Union in 1971 and the Aid flow (current US$) in United Kingdom in 1974?
Your response must be concise. 1.65e+07. What is the difference between the Aid flow (current US$) of European Union in 1971 and the Aid flow (current US$) of United States in 1974?
Your response must be concise. -4.73e+08. What is the difference between the Aid flow (current US$) in European Union in 1971 and the Aid flow (current US$) in Iceland in 1974?
Offer a very short reply. 1.13e+08. What is the difference between the Aid flow (current US$) of United Kingdom in 1971 and the Aid flow (current US$) of United States in 1974?
Provide a short and direct response. -5.23e+08. What is the difference between the Aid flow (current US$) in United Kingdom in 1971 and the Aid flow (current US$) in Iceland in 1974?
Your answer should be compact. 6.29e+07. What is the difference between the Aid flow (current US$) of United States in 1971 and the Aid flow (current US$) of Iceland in 1974?
Offer a terse response. 2.10e+08. What is the difference between the Aid flow (current US$) in European Union in 1972 and the Aid flow (current US$) in United Kingdom in 1973?
Provide a succinct answer. 2.43e+07. What is the difference between the Aid flow (current US$) in European Union in 1972 and the Aid flow (current US$) in United States in 1973?
Give a very brief answer. -3.41e+08. What is the difference between the Aid flow (current US$) in European Union in 1972 and the Aid flow (current US$) in Iceland in 1973?
Keep it short and to the point. 9.68e+07. What is the difference between the Aid flow (current US$) in United Kingdom in 1972 and the Aid flow (current US$) in United States in 1973?
Provide a succinct answer. -3.60e+08. What is the difference between the Aid flow (current US$) in United Kingdom in 1972 and the Aid flow (current US$) in Iceland in 1973?
Provide a succinct answer. 7.77e+07. What is the difference between the Aid flow (current US$) of United States in 1972 and the Aid flow (current US$) of Iceland in 1973?
Make the answer very short. 2.77e+08. What is the difference between the Aid flow (current US$) of European Union in 1972 and the Aid flow (current US$) of United Kingdom in 1974?
Your answer should be very brief. 4.35e+06. What is the difference between the Aid flow (current US$) of European Union in 1972 and the Aid flow (current US$) of United States in 1974?
Ensure brevity in your answer.  -4.85e+08. What is the difference between the Aid flow (current US$) of European Union in 1972 and the Aid flow (current US$) of Iceland in 1974?
Ensure brevity in your answer.  1.01e+08. What is the difference between the Aid flow (current US$) in United Kingdom in 1972 and the Aid flow (current US$) in United States in 1974?
Give a very brief answer. -5.04e+08. What is the difference between the Aid flow (current US$) of United Kingdom in 1972 and the Aid flow (current US$) of Iceland in 1974?
Provide a succinct answer. 8.15e+07. What is the difference between the Aid flow (current US$) of United States in 1972 and the Aid flow (current US$) of Iceland in 1974?
Your answer should be compact. 2.81e+08. What is the difference between the Aid flow (current US$) in European Union in 1973 and the Aid flow (current US$) in United Kingdom in 1974?
Ensure brevity in your answer.  1.04e+08. What is the difference between the Aid flow (current US$) in European Union in 1973 and the Aid flow (current US$) in United States in 1974?
Your answer should be compact. -3.86e+08. What is the difference between the Aid flow (current US$) in European Union in 1973 and the Aid flow (current US$) in Iceland in 1974?
Your answer should be compact. 2.00e+08. What is the difference between the Aid flow (current US$) in United Kingdom in 1973 and the Aid flow (current US$) in United States in 1974?
Give a very brief answer. -5.10e+08. What is the difference between the Aid flow (current US$) of United Kingdom in 1973 and the Aid flow (current US$) of Iceland in 1974?
Make the answer very short. 7.63e+07. What is the difference between the Aid flow (current US$) of United States in 1973 and the Aid flow (current US$) of Iceland in 1974?
Your response must be concise. 4.42e+08. What is the average Aid flow (current US$) of European Union per year?
Make the answer very short. 1.37e+08. What is the average Aid flow (current US$) of United Kingdom per year?
Offer a terse response. 8.92e+07. What is the average Aid flow (current US$) of United States per year?
Keep it short and to the point. 2.89e+08. What is the average Aid flow (current US$) in Iceland per year?
Offer a terse response. 9.55e+06. In the year 1967, what is the difference between the Aid flow (current US$) of European Union and Aid flow (current US$) of United Kingdom?
Give a very brief answer. -7.06e+07. In the year 1967, what is the difference between the Aid flow (current US$) in European Union and Aid flow (current US$) in United States?
Keep it short and to the point. -1.65e+08. In the year 1967, what is the difference between the Aid flow (current US$) of European Union and Aid flow (current US$) of Iceland?
Keep it short and to the point. 6.14e+07. In the year 1967, what is the difference between the Aid flow (current US$) of United Kingdom and Aid flow (current US$) of United States?
Keep it short and to the point. -9.42e+07. In the year 1967, what is the difference between the Aid flow (current US$) in United Kingdom and Aid flow (current US$) in Iceland?
Give a very brief answer. 1.32e+08. In the year 1967, what is the difference between the Aid flow (current US$) in United States and Aid flow (current US$) in Iceland?
Offer a very short reply. 2.26e+08. In the year 1968, what is the difference between the Aid flow (current US$) in European Union and Aid flow (current US$) in United Kingdom?
Your answer should be very brief. 2.79e+07. In the year 1968, what is the difference between the Aid flow (current US$) of European Union and Aid flow (current US$) of United States?
Provide a short and direct response. -6.87e+07. In the year 1968, what is the difference between the Aid flow (current US$) in European Union and Aid flow (current US$) in Iceland?
Your response must be concise. 1.02e+08. In the year 1968, what is the difference between the Aid flow (current US$) of United Kingdom and Aid flow (current US$) of United States?
Provide a short and direct response. -9.66e+07. In the year 1968, what is the difference between the Aid flow (current US$) in United Kingdom and Aid flow (current US$) in Iceland?
Provide a short and direct response. 7.44e+07. In the year 1968, what is the difference between the Aid flow (current US$) in United States and Aid flow (current US$) in Iceland?
Offer a very short reply. 1.71e+08. In the year 1969, what is the difference between the Aid flow (current US$) of European Union and Aid flow (current US$) of United Kingdom?
Provide a short and direct response. 4.76e+06. In the year 1969, what is the difference between the Aid flow (current US$) in European Union and Aid flow (current US$) in United States?
Your answer should be very brief. -9.58e+07. In the year 1969, what is the difference between the Aid flow (current US$) of European Union and Aid flow (current US$) of Iceland?
Provide a short and direct response. 7.44e+07. In the year 1969, what is the difference between the Aid flow (current US$) in United Kingdom and Aid flow (current US$) in United States?
Keep it short and to the point. -1.01e+08. In the year 1969, what is the difference between the Aid flow (current US$) of United Kingdom and Aid flow (current US$) of Iceland?
Offer a very short reply. 6.97e+07. In the year 1969, what is the difference between the Aid flow (current US$) of United States and Aid flow (current US$) of Iceland?
Give a very brief answer. 1.70e+08. In the year 1970, what is the difference between the Aid flow (current US$) of European Union and Aid flow (current US$) of United Kingdom?
Make the answer very short. 3.03e+07. In the year 1970, what is the difference between the Aid flow (current US$) in European Union and Aid flow (current US$) in United States?
Your answer should be compact. -7.60e+07. In the year 1970, what is the difference between the Aid flow (current US$) of European Union and Aid flow (current US$) of Iceland?
Ensure brevity in your answer.  8.26e+07. In the year 1970, what is the difference between the Aid flow (current US$) of United Kingdom and Aid flow (current US$) of United States?
Ensure brevity in your answer.  -1.06e+08. In the year 1970, what is the difference between the Aid flow (current US$) in United Kingdom and Aid flow (current US$) in Iceland?
Make the answer very short. 5.23e+07. In the year 1970, what is the difference between the Aid flow (current US$) in United States and Aid flow (current US$) in Iceland?
Keep it short and to the point. 1.59e+08. In the year 1971, what is the difference between the Aid flow (current US$) of European Union and Aid flow (current US$) of United Kingdom?
Your answer should be compact. 4.98e+07. In the year 1971, what is the difference between the Aid flow (current US$) in European Union and Aid flow (current US$) in United States?
Keep it short and to the point. -9.71e+07. In the year 1971, what is the difference between the Aid flow (current US$) of European Union and Aid flow (current US$) of Iceland?
Make the answer very short. 1.12e+08. In the year 1971, what is the difference between the Aid flow (current US$) in United Kingdom and Aid flow (current US$) in United States?
Your response must be concise. -1.47e+08. In the year 1971, what is the difference between the Aid flow (current US$) in United Kingdom and Aid flow (current US$) in Iceland?
Offer a very short reply. 6.19e+07. In the year 1971, what is the difference between the Aid flow (current US$) in United States and Aid flow (current US$) in Iceland?
Ensure brevity in your answer.  2.09e+08. In the year 1972, what is the difference between the Aid flow (current US$) of European Union and Aid flow (current US$) of United Kingdom?
Make the answer very short. 1.91e+07. In the year 1972, what is the difference between the Aid flow (current US$) in European Union and Aid flow (current US$) in United States?
Your answer should be very brief. -1.80e+08. In the year 1972, what is the difference between the Aid flow (current US$) of European Union and Aid flow (current US$) of Iceland?
Offer a very short reply. 9.76e+07. In the year 1972, what is the difference between the Aid flow (current US$) of United Kingdom and Aid flow (current US$) of United States?
Ensure brevity in your answer.  -1.99e+08. In the year 1972, what is the difference between the Aid flow (current US$) of United Kingdom and Aid flow (current US$) of Iceland?
Your answer should be very brief. 7.86e+07. In the year 1972, what is the difference between the Aid flow (current US$) of United States and Aid flow (current US$) of Iceland?
Your response must be concise. 2.78e+08. In the year 1973, what is the difference between the Aid flow (current US$) in European Union and Aid flow (current US$) in United Kingdom?
Provide a short and direct response. 1.24e+08. In the year 1973, what is the difference between the Aid flow (current US$) in European Union and Aid flow (current US$) in United States?
Ensure brevity in your answer.  -2.42e+08. In the year 1973, what is the difference between the Aid flow (current US$) of European Union and Aid flow (current US$) of Iceland?
Your answer should be compact. 1.96e+08. In the year 1973, what is the difference between the Aid flow (current US$) of United Kingdom and Aid flow (current US$) of United States?
Your answer should be compact. -3.66e+08. In the year 1973, what is the difference between the Aid flow (current US$) of United Kingdom and Aid flow (current US$) of Iceland?
Keep it short and to the point. 7.25e+07. In the year 1973, what is the difference between the Aid flow (current US$) of United States and Aid flow (current US$) of Iceland?
Keep it short and to the point. 4.38e+08. In the year 1974, what is the difference between the Aid flow (current US$) in European Union and Aid flow (current US$) in United Kingdom?
Give a very brief answer. 2.01e+08. In the year 1974, what is the difference between the Aid flow (current US$) in European Union and Aid flow (current US$) in United States?
Your answer should be compact. -2.89e+08. In the year 1974, what is the difference between the Aid flow (current US$) in European Union and Aid flow (current US$) in Iceland?
Provide a succinct answer. 2.97e+08. In the year 1974, what is the difference between the Aid flow (current US$) in United Kingdom and Aid flow (current US$) in United States?
Make the answer very short. -4.90e+08. In the year 1974, what is the difference between the Aid flow (current US$) in United Kingdom and Aid flow (current US$) in Iceland?
Provide a succinct answer. 9.62e+07. In the year 1974, what is the difference between the Aid flow (current US$) in United States and Aid flow (current US$) in Iceland?
Offer a terse response. 5.86e+08. What is the ratio of the Aid flow (current US$) of European Union in 1967 to that in 1968?
Keep it short and to the point. 0.61. What is the ratio of the Aid flow (current US$) of United Kingdom in 1967 to that in 1968?
Offer a very short reply. 1.73. What is the ratio of the Aid flow (current US$) of United States in 1967 to that in 1968?
Your response must be concise. 1.31. What is the ratio of the Aid flow (current US$) of Iceland in 1967 to that in 1968?
Offer a very short reply. 0.79. What is the ratio of the Aid flow (current US$) of European Union in 1967 to that in 1969?
Your answer should be very brief. 0.81. What is the ratio of the Aid flow (current US$) of United Kingdom in 1967 to that in 1969?
Offer a terse response. 1.82. What is the ratio of the Aid flow (current US$) in United States in 1967 to that in 1969?
Your answer should be compact. 1.31. What is the ratio of the Aid flow (current US$) of Iceland in 1967 to that in 1969?
Offer a terse response. 0.66. What is the ratio of the Aid flow (current US$) in European Union in 1967 to that in 1970?
Offer a terse response. 0.71. What is the ratio of the Aid flow (current US$) of United Kingdom in 1967 to that in 1970?
Your answer should be very brief. 2.22. What is the ratio of the Aid flow (current US$) in United States in 1967 to that in 1970?
Offer a terse response. 1.37. What is the ratio of the Aid flow (current US$) in Iceland in 1967 to that in 1970?
Give a very brief answer. 0.37. What is the ratio of the Aid flow (current US$) of European Union in 1967 to that in 1971?
Provide a short and direct response. 0.52. What is the ratio of the Aid flow (current US$) in United Kingdom in 1967 to that in 1971?
Your answer should be very brief. 1.8. What is the ratio of the Aid flow (current US$) of United States in 1967 to that in 1971?
Provide a succinct answer. 1.03. What is the ratio of the Aid flow (current US$) of Iceland in 1967 to that in 1971?
Your response must be concise. 0.24. What is the ratio of the Aid flow (current US$) of European Union in 1967 to that in 1972?
Ensure brevity in your answer.  0.57. What is the ratio of the Aid flow (current US$) of United Kingdom in 1967 to that in 1972?
Give a very brief answer. 1.44. What is the ratio of the Aid flow (current US$) of United States in 1967 to that in 1972?
Ensure brevity in your answer.  0.78. What is the ratio of the Aid flow (current US$) in Iceland in 1967 to that in 1972?
Offer a terse response. 0.21. What is the ratio of the Aid flow (current US$) of European Union in 1967 to that in 1973?
Provide a succinct answer. 0.3. What is the ratio of the Aid flow (current US$) in United Kingdom in 1967 to that in 1973?
Offer a very short reply. 1.53. What is the ratio of the Aid flow (current US$) of United States in 1967 to that in 1973?
Make the answer very short. 0.51. What is the ratio of the Aid flow (current US$) in Iceland in 1967 to that in 1973?
Provide a short and direct response. 0.2. What is the ratio of the Aid flow (current US$) of European Union in 1967 to that in 1974?
Ensure brevity in your answer.  0.21. What is the ratio of the Aid flow (current US$) of United Kingdom in 1967 to that in 1974?
Ensure brevity in your answer.  1.25. What is the ratio of the Aid flow (current US$) in United States in 1967 to that in 1974?
Offer a terse response. 0.38. What is the ratio of the Aid flow (current US$) in Iceland in 1967 to that in 1974?
Ensure brevity in your answer.  0.26. What is the ratio of the Aid flow (current US$) of European Union in 1968 to that in 1969?
Keep it short and to the point. 1.34. What is the ratio of the Aid flow (current US$) in United Kingdom in 1968 to that in 1969?
Your answer should be compact. 1.05. What is the ratio of the Aid flow (current US$) of United States in 1968 to that in 1969?
Make the answer very short. 1. What is the ratio of the Aid flow (current US$) in Iceland in 1968 to that in 1969?
Offer a terse response. 0.83. What is the ratio of the Aid flow (current US$) of European Union in 1968 to that in 1970?
Offer a very short reply. 1.17. What is the ratio of the Aid flow (current US$) in United Kingdom in 1968 to that in 1970?
Make the answer very short. 1.29. What is the ratio of the Aid flow (current US$) in United States in 1968 to that in 1970?
Your answer should be very brief. 1.05. What is the ratio of the Aid flow (current US$) of Iceland in 1968 to that in 1970?
Give a very brief answer. 0.47. What is the ratio of the Aid flow (current US$) in European Union in 1968 to that in 1971?
Your response must be concise. 0.85. What is the ratio of the Aid flow (current US$) of United Kingdom in 1968 to that in 1971?
Your response must be concise. 1.04. What is the ratio of the Aid flow (current US$) of United States in 1968 to that in 1971?
Your answer should be very brief. 0.79. What is the ratio of the Aid flow (current US$) of Iceland in 1968 to that in 1971?
Ensure brevity in your answer.  0.3. What is the ratio of the Aid flow (current US$) in European Union in 1968 to that in 1972?
Your response must be concise. 0.94. What is the ratio of the Aid flow (current US$) in United Kingdom in 1968 to that in 1972?
Provide a succinct answer. 0.84. What is the ratio of the Aid flow (current US$) in United States in 1968 to that in 1972?
Offer a terse response. 0.6. What is the ratio of the Aid flow (current US$) of Iceland in 1968 to that in 1972?
Ensure brevity in your answer.  0.26. What is the ratio of the Aid flow (current US$) of European Union in 1968 to that in 1973?
Ensure brevity in your answer.  0.5. What is the ratio of the Aid flow (current US$) of United Kingdom in 1968 to that in 1973?
Offer a terse response. 0.89. What is the ratio of the Aid flow (current US$) in United States in 1968 to that in 1973?
Offer a terse response. 0.39. What is the ratio of the Aid flow (current US$) of Iceland in 1968 to that in 1973?
Give a very brief answer. 0.25. What is the ratio of the Aid flow (current US$) in European Union in 1968 to that in 1974?
Provide a succinct answer. 0.34. What is the ratio of the Aid flow (current US$) in United Kingdom in 1968 to that in 1974?
Your answer should be very brief. 0.72. What is the ratio of the Aid flow (current US$) in United States in 1968 to that in 1974?
Offer a very short reply. 0.29. What is the ratio of the Aid flow (current US$) of Iceland in 1968 to that in 1974?
Make the answer very short. 0.33. What is the ratio of the Aid flow (current US$) in European Union in 1969 to that in 1970?
Give a very brief answer. 0.87. What is the ratio of the Aid flow (current US$) in United Kingdom in 1969 to that in 1970?
Make the answer very short. 1.23. What is the ratio of the Aid flow (current US$) of United States in 1969 to that in 1970?
Your answer should be very brief. 1.05. What is the ratio of the Aid flow (current US$) in Iceland in 1969 to that in 1970?
Provide a short and direct response. 0.56. What is the ratio of the Aid flow (current US$) of European Union in 1969 to that in 1971?
Ensure brevity in your answer.  0.63. What is the ratio of the Aid flow (current US$) of United States in 1969 to that in 1971?
Offer a very short reply. 0.79. What is the ratio of the Aid flow (current US$) of Iceland in 1969 to that in 1971?
Provide a succinct answer. 0.36. What is the ratio of the Aid flow (current US$) of European Union in 1969 to that in 1972?
Give a very brief answer. 0.7. What is the ratio of the Aid flow (current US$) of United Kingdom in 1969 to that in 1972?
Make the answer very short. 0.8. What is the ratio of the Aid flow (current US$) in United States in 1969 to that in 1972?
Keep it short and to the point. 0.6. What is the ratio of the Aid flow (current US$) of Iceland in 1969 to that in 1972?
Your answer should be compact. 0.32. What is the ratio of the Aid flow (current US$) in European Union in 1969 to that in 1973?
Your response must be concise. 0.37. What is the ratio of the Aid flow (current US$) in United Kingdom in 1969 to that in 1973?
Make the answer very short. 0.84. What is the ratio of the Aid flow (current US$) of United States in 1969 to that in 1973?
Provide a short and direct response. 0.39. What is the ratio of the Aid flow (current US$) of Iceland in 1969 to that in 1973?
Provide a succinct answer. 0.3. What is the ratio of the Aid flow (current US$) in European Union in 1969 to that in 1974?
Your answer should be compact. 0.26. What is the ratio of the Aid flow (current US$) in United Kingdom in 1969 to that in 1974?
Provide a short and direct response. 0.69. What is the ratio of the Aid flow (current US$) in United States in 1969 to that in 1974?
Your answer should be compact. 0.29. What is the ratio of the Aid flow (current US$) in Iceland in 1969 to that in 1974?
Provide a short and direct response. 0.39. What is the ratio of the Aid flow (current US$) in European Union in 1970 to that in 1971?
Provide a short and direct response. 0.73. What is the ratio of the Aid flow (current US$) in United Kingdom in 1970 to that in 1971?
Provide a short and direct response. 0.81. What is the ratio of the Aid flow (current US$) in United States in 1970 to that in 1971?
Your response must be concise. 0.75. What is the ratio of the Aid flow (current US$) in Iceland in 1970 to that in 1971?
Your answer should be compact. 0.65. What is the ratio of the Aid flow (current US$) in European Union in 1970 to that in 1972?
Give a very brief answer. 0.81. What is the ratio of the Aid flow (current US$) of United Kingdom in 1970 to that in 1972?
Your response must be concise. 0.65. What is the ratio of the Aid flow (current US$) in United States in 1970 to that in 1972?
Your response must be concise. 0.57. What is the ratio of the Aid flow (current US$) in Iceland in 1970 to that in 1972?
Offer a terse response. 0.56. What is the ratio of the Aid flow (current US$) in European Union in 1970 to that in 1973?
Make the answer very short. 0.43. What is the ratio of the Aid flow (current US$) of United Kingdom in 1970 to that in 1973?
Your answer should be very brief. 0.69. What is the ratio of the Aid flow (current US$) in United States in 1970 to that in 1973?
Your response must be concise. 0.37. What is the ratio of the Aid flow (current US$) of Iceland in 1970 to that in 1973?
Keep it short and to the point. 0.53. What is the ratio of the Aid flow (current US$) of European Union in 1970 to that in 1974?
Your answer should be compact. 0.29. What is the ratio of the Aid flow (current US$) in United Kingdom in 1970 to that in 1974?
Give a very brief answer. 0.56. What is the ratio of the Aid flow (current US$) in United States in 1970 to that in 1974?
Give a very brief answer. 0.28. What is the ratio of the Aid flow (current US$) in Iceland in 1970 to that in 1974?
Offer a terse response. 0.7. What is the ratio of the Aid flow (current US$) of European Union in 1971 to that in 1972?
Keep it short and to the point. 1.11. What is the ratio of the Aid flow (current US$) in United Kingdom in 1971 to that in 1972?
Provide a succinct answer. 0.8. What is the ratio of the Aid flow (current US$) of United States in 1971 to that in 1972?
Make the answer very short. 0.76. What is the ratio of the Aid flow (current US$) of Iceland in 1971 to that in 1972?
Offer a very short reply. 0.87. What is the ratio of the Aid flow (current US$) of European Union in 1971 to that in 1973?
Provide a short and direct response. 0.59. What is the ratio of the Aid flow (current US$) of United Kingdom in 1971 to that in 1973?
Ensure brevity in your answer.  0.85. What is the ratio of the Aid flow (current US$) of United States in 1971 to that in 1973?
Give a very brief answer. 0.49. What is the ratio of the Aid flow (current US$) in Iceland in 1971 to that in 1973?
Keep it short and to the point. 0.82. What is the ratio of the Aid flow (current US$) of European Union in 1971 to that in 1974?
Your answer should be very brief. 0.4. What is the ratio of the Aid flow (current US$) in United Kingdom in 1971 to that in 1974?
Provide a succinct answer. 0.69. What is the ratio of the Aid flow (current US$) in United States in 1971 to that in 1974?
Your answer should be compact. 0.37. What is the ratio of the Aid flow (current US$) in Iceland in 1971 to that in 1974?
Your answer should be compact. 1.08. What is the ratio of the Aid flow (current US$) in European Union in 1972 to that in 1973?
Give a very brief answer. 0.53. What is the ratio of the Aid flow (current US$) of United Kingdom in 1972 to that in 1973?
Provide a succinct answer. 1.06. What is the ratio of the Aid flow (current US$) in United States in 1972 to that in 1973?
Your response must be concise. 0.65. What is the ratio of the Aid flow (current US$) in Iceland in 1972 to that in 1973?
Provide a succinct answer. 0.95. What is the ratio of the Aid flow (current US$) of European Union in 1972 to that in 1974?
Offer a terse response. 0.36. What is the ratio of the Aid flow (current US$) of United Kingdom in 1972 to that in 1974?
Your answer should be compact. 0.86. What is the ratio of the Aid flow (current US$) in United States in 1972 to that in 1974?
Your response must be concise. 0.49. What is the ratio of the Aid flow (current US$) in Iceland in 1972 to that in 1974?
Provide a short and direct response. 1.25. What is the ratio of the Aid flow (current US$) in European Union in 1973 to that in 1974?
Provide a short and direct response. 0.69. What is the ratio of the Aid flow (current US$) in United Kingdom in 1973 to that in 1974?
Your answer should be very brief. 0.82. What is the ratio of the Aid flow (current US$) in United States in 1973 to that in 1974?
Provide a succinct answer. 0.76. What is the ratio of the Aid flow (current US$) of Iceland in 1973 to that in 1974?
Provide a short and direct response. 1.32. What is the difference between the highest and the second highest Aid flow (current US$) in European Union?
Your answer should be compact. 9.74e+07. What is the difference between the highest and the second highest Aid flow (current US$) in United Kingdom?
Your answer should be compact. 2.68e+07. What is the difference between the highest and the second highest Aid flow (current US$) of United States?
Give a very brief answer. 1.44e+08. What is the difference between the highest and the second highest Aid flow (current US$) in Iceland?
Your answer should be very brief. 8.60e+05. What is the difference between the highest and the lowest Aid flow (current US$) in European Union?
Offer a terse response. 2.45e+08. What is the difference between the highest and the lowest Aid flow (current US$) of United Kingdom?
Your response must be concise. 7.44e+07. What is the difference between the highest and the lowest Aid flow (current US$) of United States?
Give a very brief answer. 4.31e+08. What is the difference between the highest and the lowest Aid flow (current US$) in Iceland?
Your response must be concise. 1.28e+07. 